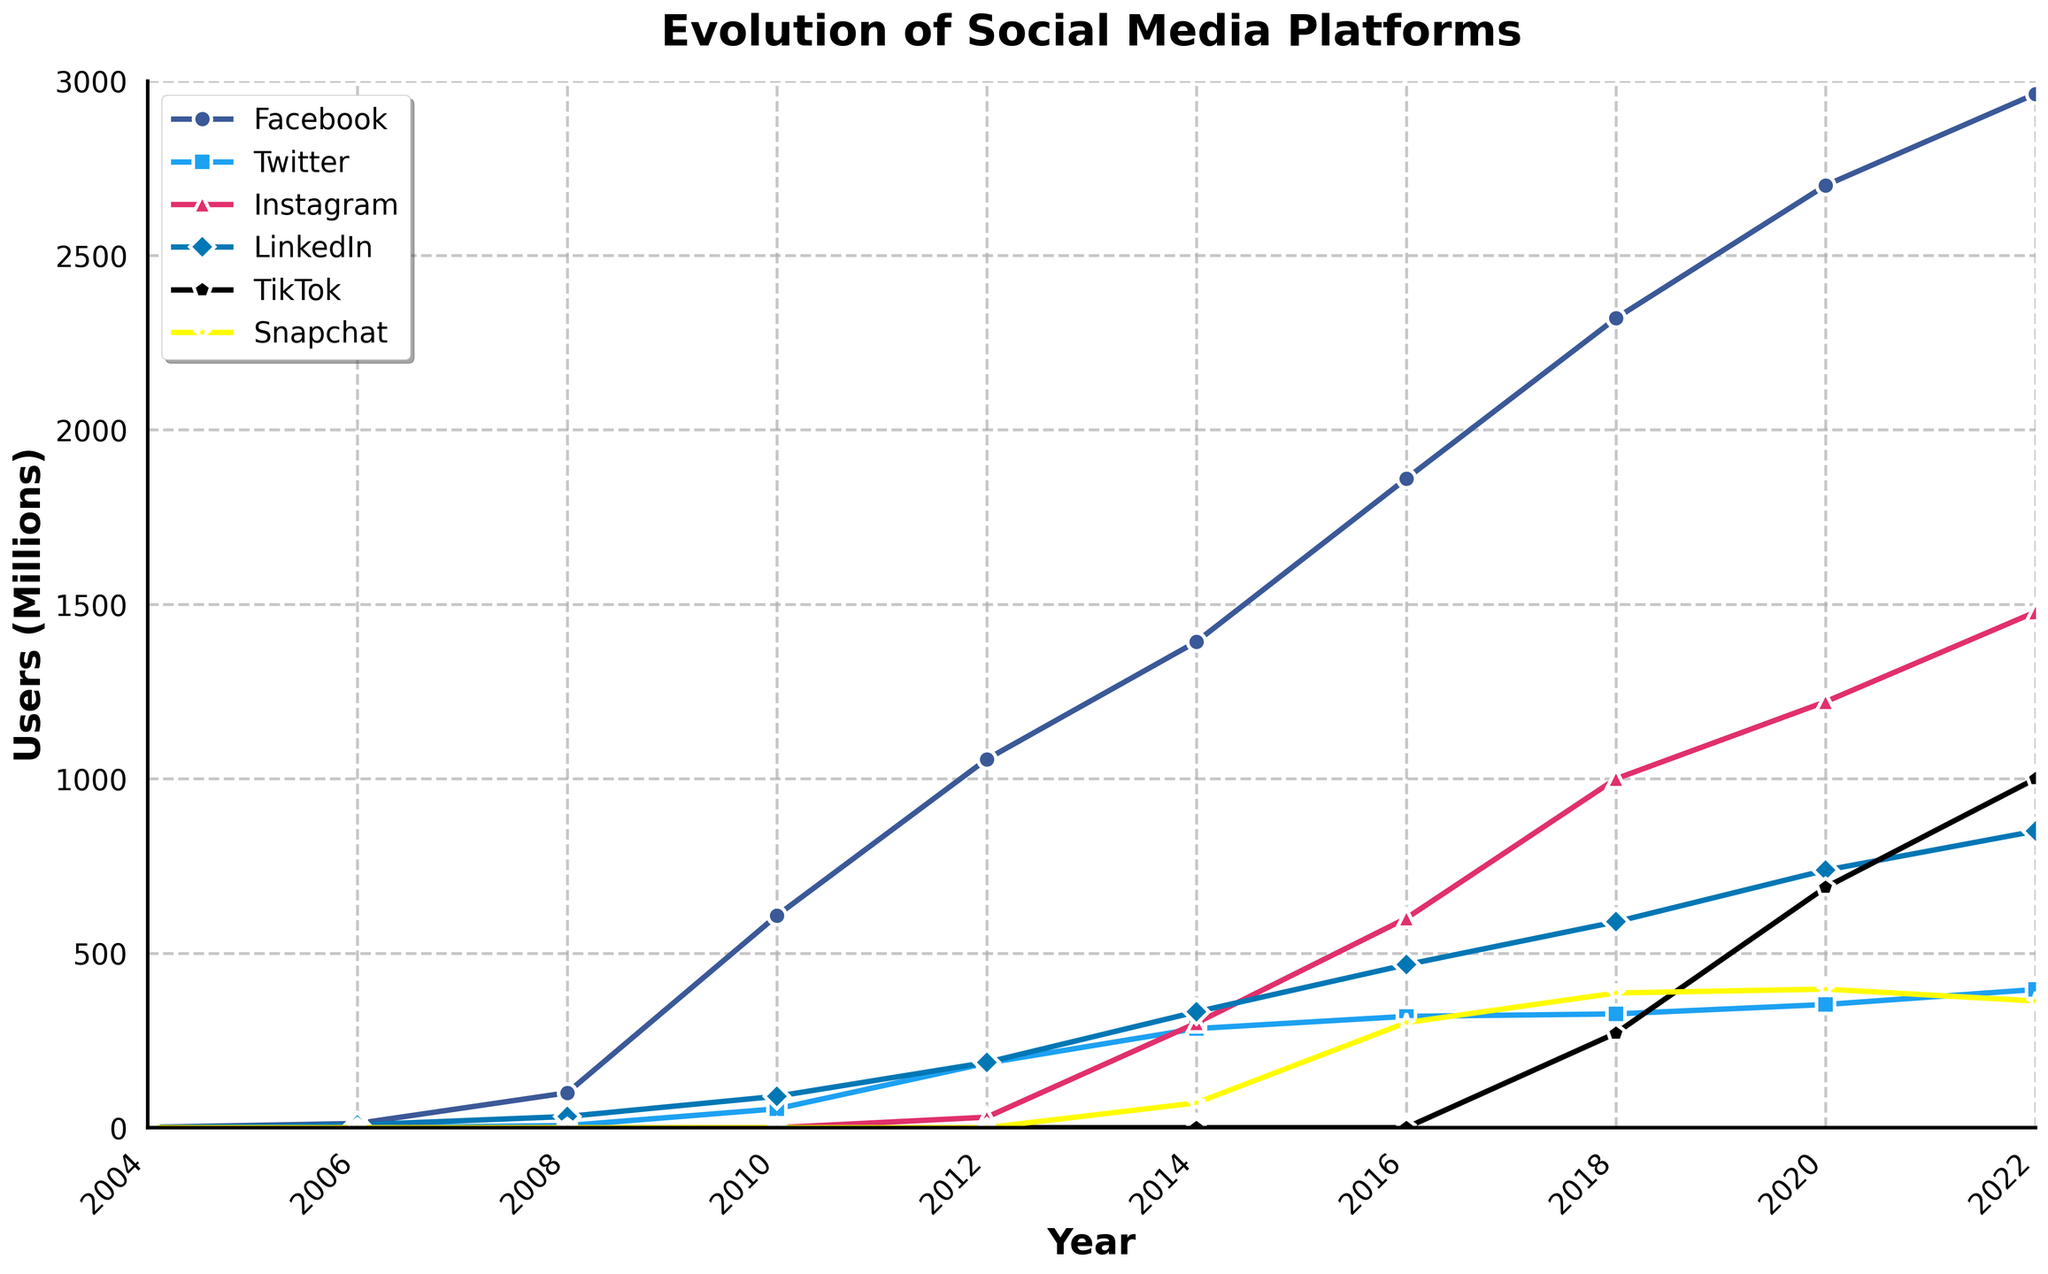What was the user base of Facebook in 2010 compared to Twitter? In 2010, Facebook had around 608 million users. In the same year, Twitter had around 54 million users. By comparing these two numbers, we can see that Facebook had a significantly larger user base than Twitter in 2010.
Answer: Facebook had 554 million more users than Twitter in 2010 Which social media platform had the largest growth in users from 2016 to 2018? By looking at the plot, we observe the two data points for each platform in those years. Facebook grew from 1.86 billion to 2.32 billion (460 million). Twitter grew from 319 million to 326 million (7 million). Instagram grew from 600 million to 1 billion (400 million). LinkedIn grew from 467 million to 590 million (123 million). TikTok grew from 0 to 271 million (271 million) as it was launched in 2018. Snapchat grew from 301 million to 386 million (85 million). Facebook shows the largest increase with 460 million users.
Answer: Facebook had the largest growth In which year did Instagram surpass the 1 billion user mark? The plot shows Instagram's user growth over the years. It only surpasses 1 billion users between 2016 and 2018. In 2018, Instagram's user base is labeled as 1 billion, confirming that in 2018, Instagram surpassed the 1 billion user mark.
Answer: 2018 From 2020 to 2022, which platform gained more users: Twitter or TikTok? By observing the plot, we compare Twitter's growth from 353 million to 396 million (43 million growth) and TikTok's growth from 689 million to 1 billion (311 million growth) from 2020 to 2022. TikTok clearly outperformed Twitter in gaining users during this period by a vast difference.
Answer: TikTok gained more users How many total users did all platforms combined have in 2022? To find the total, we sum the users of all six platforms in 2022: Facebook (2963 million), Twitter (396 million), Instagram (1478 million), LinkedIn (850 million), TikTok (1000 million), and Snapchat (363 million). Adding these gives (2963 + 396 + 1478 + 850 + 1000 + 363 = 7050 million). Therefore, all platforms combined had 7.05 billion users in 2022.
Answer: 7.05 billion Which platform had no users in 2008 and how many platforms had users then? TikTok did not exist in 2008, and thus had zero users, whereas Facebook, Twitter, and LinkedIn had user bases. Instagram and Snapchat are not shown to have user bases in 2008 either. This means only Facebook, Twitter, and LinkedIn had users in 2008.
Answer: TikTok had no users, and three platforms had users How does the user count of Snapchat in 2016 compare to LinkedIn in 2010? We observe that Snapchat's user count in 2016 is around 301 million, whereas LinkedIn's user count in 2010 is around 90 million. By comparing these values, Snapchat in 2016 had about 211 million more users than LinkedIn in 2010.
Answer: Snapchat had 211 million more users Between 2008 and 2010, which platform saw the highest growth in users? Looking at the plot, Facebook grew from 100 million to 608 million (508 million increase). Twitter grew from 6 million to 54 million (48 million increase). LinkedIn grew from 32 million to 90 million (58 million increase). Since Instagram, TikTok, and Snapchat had no users and LinkedIn/tweetler had lower growth, Facebook’s growth is the highest in this period.
Answer: Facebook saw the highest growth 